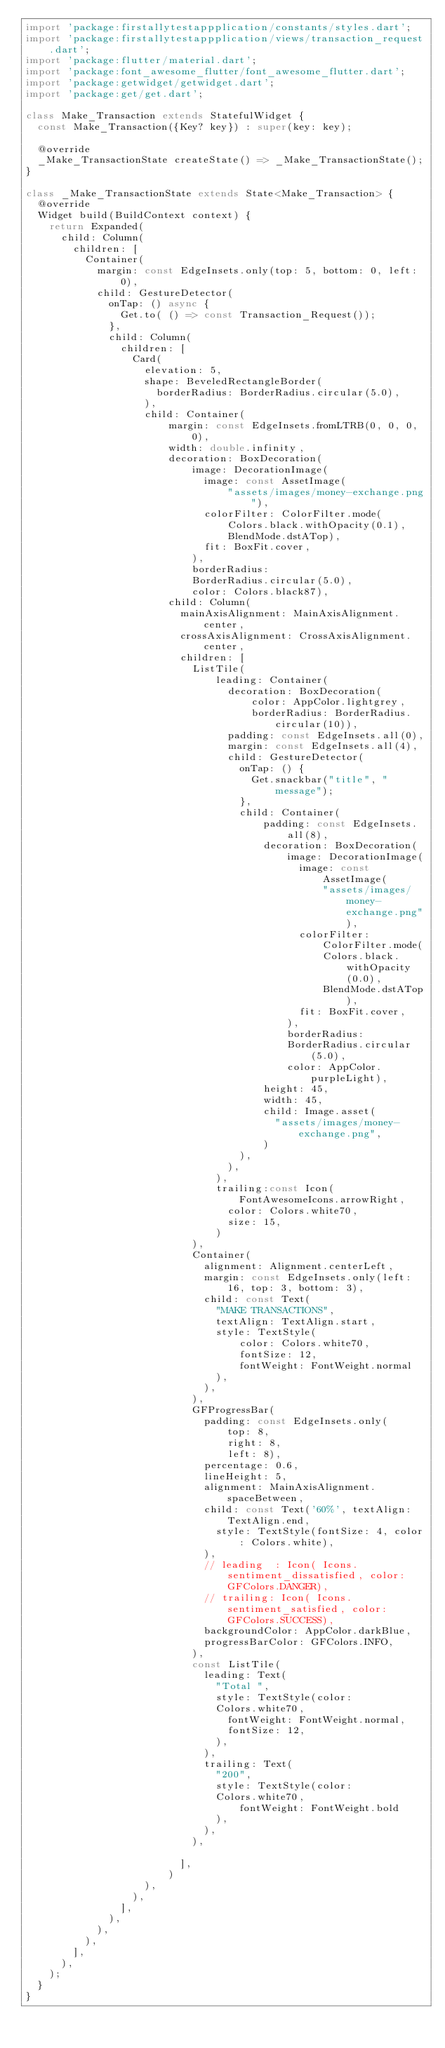<code> <loc_0><loc_0><loc_500><loc_500><_Dart_>import 'package:firstallytestappplication/constants/styles.dart';
import 'package:firstallytestappplication/views/transaction_request.dart';
import 'package:flutter/material.dart';
import 'package:font_awesome_flutter/font_awesome_flutter.dart';
import 'package:getwidget/getwidget.dart';
import 'package:get/get.dart';

class Make_Transaction extends StatefulWidget {
  const Make_Transaction({Key? key}) : super(key: key);

  @override
  _Make_TransactionState createState() => _Make_TransactionState();
}

class _Make_TransactionState extends State<Make_Transaction> {
  @override
  Widget build(BuildContext context) {
    return Expanded(
      child: Column(
        children: [
          Container(
            margin: const EdgeInsets.only(top: 5, bottom: 0, left: 0),
            child: GestureDetector(
              onTap: () async {
                Get.to( () => const Transaction_Request());
              },
              child: Column(
                children: [
                  Card(
                    elevation: 5,
                    shape: BeveledRectangleBorder(
                      borderRadius: BorderRadius.circular(5.0),
                    ),
                    child: Container(
                        margin: const EdgeInsets.fromLTRB(0, 0, 0, 0),
                        width: double.infinity,
                        decoration: BoxDecoration(
                            image: DecorationImage(
                              image: const AssetImage(
                                  "assets/images/money-exchange.png"),
                              colorFilter: ColorFilter.mode(
                                  Colors.black.withOpacity(0.1),
                                  BlendMode.dstATop),
                              fit: BoxFit.cover,
                            ),
                            borderRadius:
                            BorderRadius.circular(5.0),
                            color: Colors.black87),
                        child: Column(
                          mainAxisAlignment: MainAxisAlignment.center,
                          crossAxisAlignment: CrossAxisAlignment.center,
                          children: [
                            ListTile(
                                leading: Container(
                                  decoration: BoxDecoration(
                                      color: AppColor.lightgrey,
                                      borderRadius: BorderRadius.circular(10)),
                                  padding: const EdgeInsets.all(0),
                                  margin: const EdgeInsets.all(4),
                                  child: GestureDetector(
                                    onTap: () {
                                      Get.snackbar("title", "message");
                                    },
                                    child: Container(
                                        padding: const EdgeInsets.all(8),
                                        decoration: BoxDecoration(
                                            image: DecorationImage(
                                              image: const AssetImage(
                                                  "assets/images/money-exchange.png"),
                                              colorFilter: ColorFilter.mode(
                                                  Colors.black.withOpacity(0.0),
                                                  BlendMode.dstATop),
                                              fit: BoxFit.cover,
                                            ),
                                            borderRadius:
                                            BorderRadius.circular(5.0),
                                            color: AppColor.purpleLight),
                                        height: 45,
                                        width: 45,
                                        child: Image.asset(
                                          "assets/images/money-exchange.png",
                                        )
                                    ),
                                  ),
                                ),
                                trailing:const Icon(FontAwesomeIcons.arrowRight,
                                  color: Colors.white70,
                                  size: 15,
                                )
                            ),
                            Container(
                              alignment: Alignment.centerLeft,
                              margin: const EdgeInsets.only(left: 16, top: 3, bottom: 3),
                              child: const Text(
                                "MAKE TRANSACTIONS",
                                textAlign: TextAlign.start,
                                style: TextStyle(
                                    color: Colors.white70,
                                    fontSize: 12,
                                    fontWeight: FontWeight.normal
                                ),
                              ),
                            ),
                            GFProgressBar(
                              padding: const EdgeInsets.only(
                                  top: 8,
                                  right: 8,
                                  left: 8),
                              percentage: 0.6,
                              lineHeight: 5,
                              alignment: MainAxisAlignment.spaceBetween,
                              child: const Text('60%', textAlign: TextAlign.end,
                                style: TextStyle(fontSize: 4, color: Colors.white),
                              ),
                              // leading  : Icon( Icons.sentiment_dissatisfied, color: GFColors.DANGER),
                              // trailing: Icon( Icons.sentiment_satisfied, color: GFColors.SUCCESS),
                              backgroundColor: AppColor.darkBlue,
                              progressBarColor: GFColors.INFO,
                            ),
                            const ListTile(
                              leading: Text(
                                "Total ",
                                style: TextStyle(color:
                                Colors.white70,
                                  fontWeight: FontWeight.normal,
                                  fontSize: 12,
                                ),
                              ),
                              trailing: Text(
                                "200",
                                style: TextStyle(color:
                                Colors.white70,
                                    fontWeight: FontWeight.bold
                                ),
                              ),
                            ),

                          ],
                        )
                    ),
                  ),
                ],
              ),
            ),
          ),
        ],
      ),
    );
  }
}
</code> 